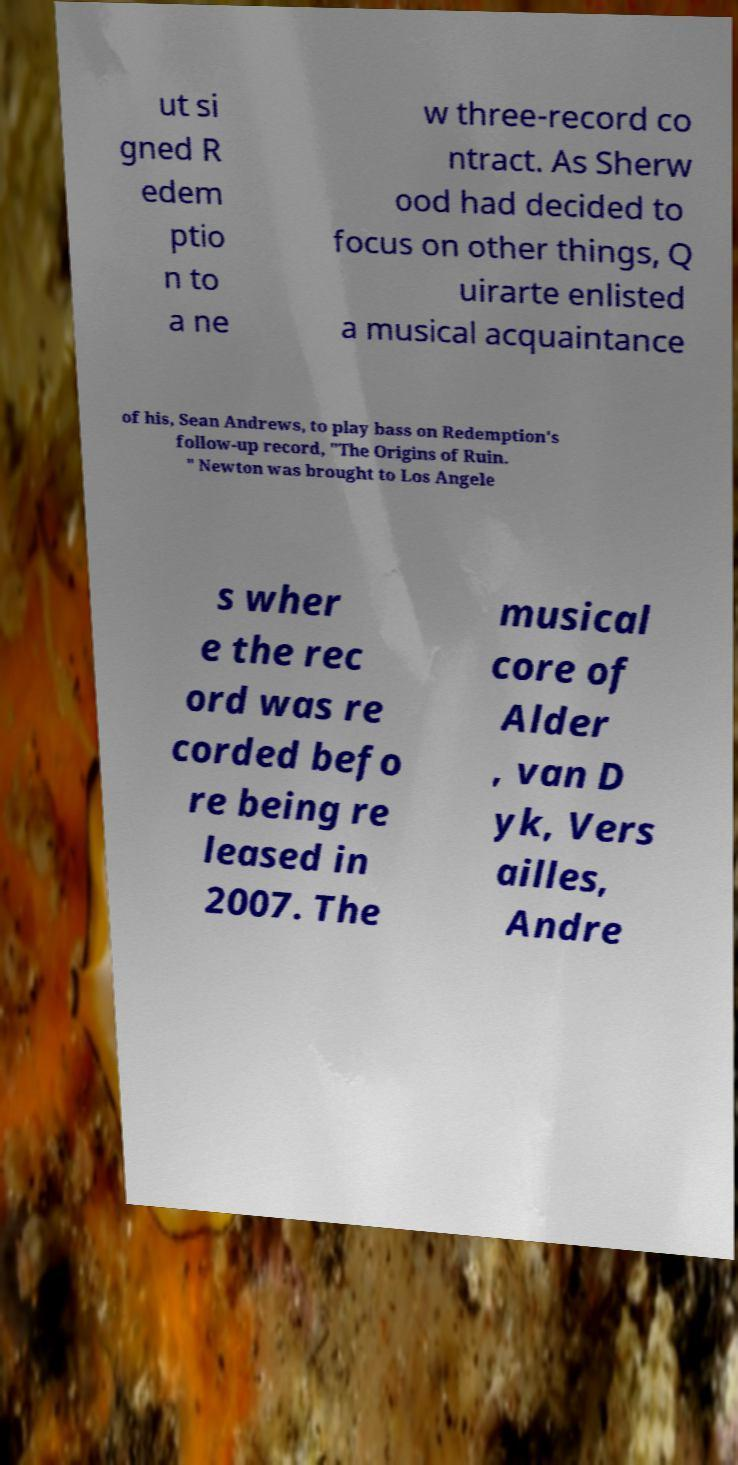Can you read and provide the text displayed in the image?This photo seems to have some interesting text. Can you extract and type it out for me? ut si gned R edem ptio n to a ne w three-record co ntract. As Sherw ood had decided to focus on other things, Q uirarte enlisted a musical acquaintance of his, Sean Andrews, to play bass on Redemption's follow-up record, "The Origins of Ruin. " Newton was brought to Los Angele s wher e the rec ord was re corded befo re being re leased in 2007. The musical core of Alder , van D yk, Vers ailles, Andre 